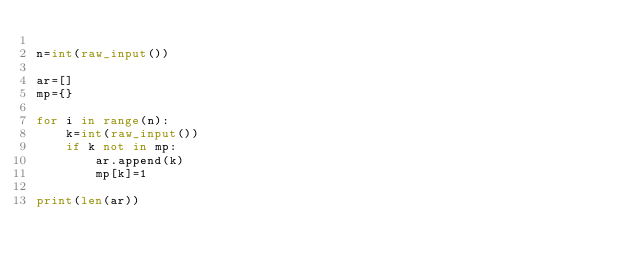Convert code to text. <code><loc_0><loc_0><loc_500><loc_500><_Python_>
n=int(raw_input())

ar=[]
mp={}

for i in range(n):
	k=int(raw_input())
	if k not in mp:
		ar.append(k)
		mp[k]=1

print(len(ar))
</code> 